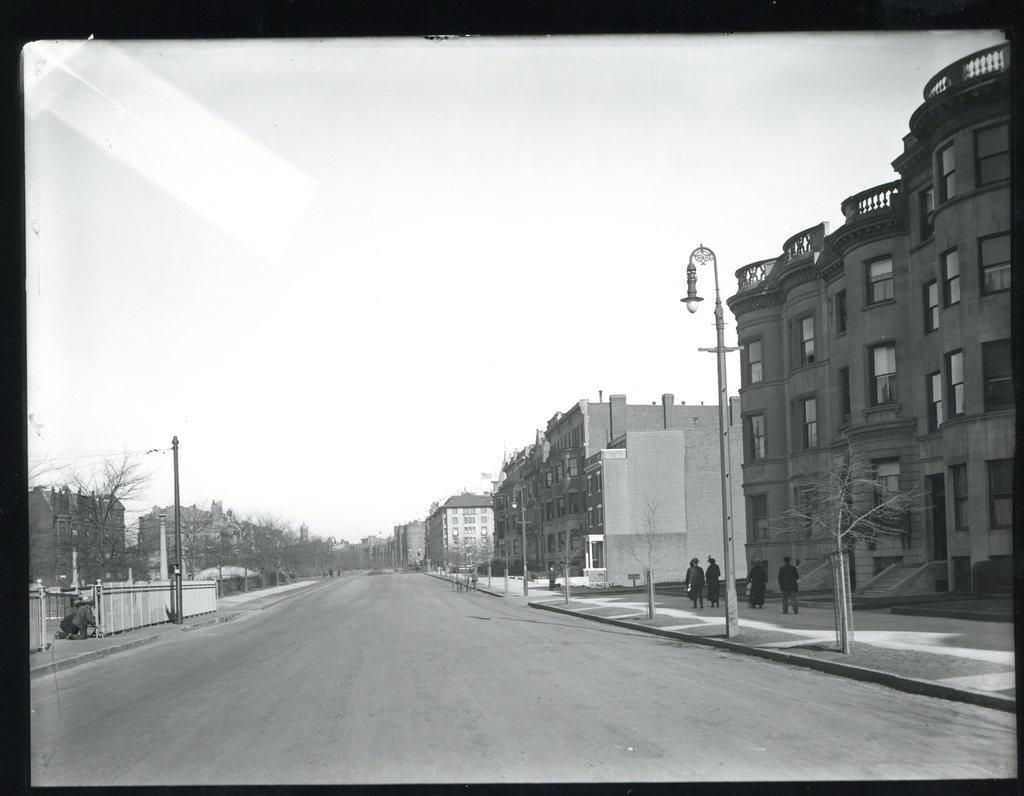In one or two sentences, can you explain what this image depicts? This is a black and white picture. Here, we see people walking on the footpath. At the bottom of the picture, we see the road. On either side of the road, We see street lights and poles. On the right side, there are buildings. On the left side, we see an iron railing and there are many trees. At the top of the picture, we see the sky. 